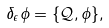<formula> <loc_0><loc_0><loc_500><loc_500>\delta _ { \epsilon } \phi = \{ \mathcal { Q } , \phi \} ,</formula> 